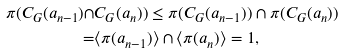Convert formula to latex. <formula><loc_0><loc_0><loc_500><loc_500>\pi ( C _ { G } ( a _ { n - 1 } ) \cap & C _ { G } ( a _ { n } ) ) \leq \pi ( C _ { G } ( a _ { n - 1 } ) ) \cap \pi ( C _ { G } ( a _ { n } ) ) \\ = & \langle \pi ( a _ { n - 1 } ) \rangle \cap \langle \pi ( a _ { n } ) \rangle = 1 ,</formula> 